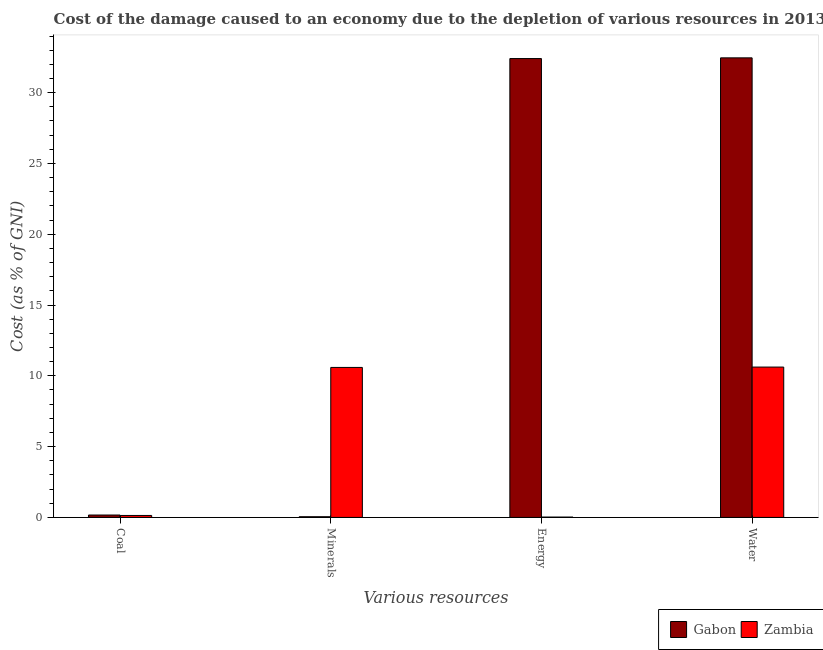How many different coloured bars are there?
Provide a succinct answer. 2. How many bars are there on the 2nd tick from the left?
Offer a very short reply. 2. What is the label of the 4th group of bars from the left?
Make the answer very short. Water. What is the cost of damage due to depletion of energy in Zambia?
Your answer should be compact. 0.03. Across all countries, what is the maximum cost of damage due to depletion of water?
Provide a short and direct response. 32.46. Across all countries, what is the minimum cost of damage due to depletion of water?
Ensure brevity in your answer.  10.62. In which country was the cost of damage due to depletion of minerals maximum?
Offer a terse response. Zambia. In which country was the cost of damage due to depletion of minerals minimum?
Provide a succinct answer. Gabon. What is the total cost of damage due to depletion of coal in the graph?
Ensure brevity in your answer.  0.31. What is the difference between the cost of damage due to depletion of energy in Zambia and that in Gabon?
Keep it short and to the point. -32.38. What is the difference between the cost of damage due to depletion of minerals in Zambia and the cost of damage due to depletion of water in Gabon?
Offer a very short reply. -21.86. What is the average cost of damage due to depletion of minerals per country?
Your answer should be very brief. 5.32. What is the difference between the cost of damage due to depletion of coal and cost of damage due to depletion of water in Gabon?
Provide a succinct answer. -32.29. What is the ratio of the cost of damage due to depletion of minerals in Gabon to that in Zambia?
Provide a succinct answer. 0. Is the cost of damage due to depletion of coal in Gabon less than that in Zambia?
Keep it short and to the point. No. What is the difference between the highest and the second highest cost of damage due to depletion of minerals?
Ensure brevity in your answer.  10.54. What is the difference between the highest and the lowest cost of damage due to depletion of water?
Offer a terse response. 21.84. In how many countries, is the cost of damage due to depletion of energy greater than the average cost of damage due to depletion of energy taken over all countries?
Provide a short and direct response. 1. Is the sum of the cost of damage due to depletion of coal in Zambia and Gabon greater than the maximum cost of damage due to depletion of minerals across all countries?
Give a very brief answer. No. Is it the case that in every country, the sum of the cost of damage due to depletion of water and cost of damage due to depletion of minerals is greater than the sum of cost of damage due to depletion of energy and cost of damage due to depletion of coal?
Keep it short and to the point. No. What does the 1st bar from the left in Coal represents?
Provide a succinct answer. Gabon. What does the 1st bar from the right in Energy represents?
Give a very brief answer. Zambia. How many bars are there?
Ensure brevity in your answer.  8. What is the difference between two consecutive major ticks on the Y-axis?
Your answer should be very brief. 5. Does the graph contain grids?
Your answer should be compact. No. Where does the legend appear in the graph?
Ensure brevity in your answer.  Bottom right. What is the title of the graph?
Your answer should be very brief. Cost of the damage caused to an economy due to the depletion of various resources in 2013 . What is the label or title of the X-axis?
Give a very brief answer. Various resources. What is the label or title of the Y-axis?
Ensure brevity in your answer.  Cost (as % of GNI). What is the Cost (as % of GNI) of Gabon in Coal?
Make the answer very short. 0.17. What is the Cost (as % of GNI) of Zambia in Coal?
Provide a short and direct response. 0.14. What is the Cost (as % of GNI) of Gabon in Minerals?
Provide a succinct answer. 0.05. What is the Cost (as % of GNI) of Zambia in Minerals?
Your answer should be very brief. 10.59. What is the Cost (as % of GNI) in Gabon in Energy?
Provide a short and direct response. 32.41. What is the Cost (as % of GNI) in Zambia in Energy?
Give a very brief answer. 0.03. What is the Cost (as % of GNI) in Gabon in Water?
Make the answer very short. 32.46. What is the Cost (as % of GNI) in Zambia in Water?
Offer a very short reply. 10.62. Across all Various resources, what is the maximum Cost (as % of GNI) of Gabon?
Offer a terse response. 32.46. Across all Various resources, what is the maximum Cost (as % of GNI) in Zambia?
Make the answer very short. 10.62. Across all Various resources, what is the minimum Cost (as % of GNI) of Gabon?
Your answer should be compact. 0.05. Across all Various resources, what is the minimum Cost (as % of GNI) of Zambia?
Give a very brief answer. 0.03. What is the total Cost (as % of GNI) of Gabon in the graph?
Give a very brief answer. 65.09. What is the total Cost (as % of GNI) of Zambia in the graph?
Your response must be concise. 21.38. What is the difference between the Cost (as % of GNI) of Gabon in Coal and that in Minerals?
Provide a short and direct response. 0.12. What is the difference between the Cost (as % of GNI) of Zambia in Coal and that in Minerals?
Give a very brief answer. -10.46. What is the difference between the Cost (as % of GNI) in Gabon in Coal and that in Energy?
Keep it short and to the point. -32.24. What is the difference between the Cost (as % of GNI) in Zambia in Coal and that in Energy?
Provide a short and direct response. 0.11. What is the difference between the Cost (as % of GNI) of Gabon in Coal and that in Water?
Your answer should be compact. -32.29. What is the difference between the Cost (as % of GNI) in Zambia in Coal and that in Water?
Provide a short and direct response. -10.48. What is the difference between the Cost (as % of GNI) in Gabon in Minerals and that in Energy?
Your answer should be compact. -32.36. What is the difference between the Cost (as % of GNI) of Zambia in Minerals and that in Energy?
Ensure brevity in your answer.  10.57. What is the difference between the Cost (as % of GNI) in Gabon in Minerals and that in Water?
Provide a succinct answer. -32.41. What is the difference between the Cost (as % of GNI) of Zambia in Minerals and that in Water?
Provide a succinct answer. -0.03. What is the difference between the Cost (as % of GNI) of Gabon in Energy and that in Water?
Make the answer very short. -0.05. What is the difference between the Cost (as % of GNI) of Zambia in Energy and that in Water?
Your response must be concise. -10.59. What is the difference between the Cost (as % of GNI) in Gabon in Coal and the Cost (as % of GNI) in Zambia in Minerals?
Make the answer very short. -10.42. What is the difference between the Cost (as % of GNI) of Gabon in Coal and the Cost (as % of GNI) of Zambia in Energy?
Your response must be concise. 0.15. What is the difference between the Cost (as % of GNI) of Gabon in Coal and the Cost (as % of GNI) of Zambia in Water?
Ensure brevity in your answer.  -10.45. What is the difference between the Cost (as % of GNI) in Gabon in Minerals and the Cost (as % of GNI) in Zambia in Energy?
Offer a very short reply. 0.02. What is the difference between the Cost (as % of GNI) in Gabon in Minerals and the Cost (as % of GNI) in Zambia in Water?
Provide a short and direct response. -10.57. What is the difference between the Cost (as % of GNI) in Gabon in Energy and the Cost (as % of GNI) in Zambia in Water?
Keep it short and to the point. 21.79. What is the average Cost (as % of GNI) of Gabon per Various resources?
Offer a very short reply. 16.27. What is the average Cost (as % of GNI) in Zambia per Various resources?
Your answer should be compact. 5.34. What is the difference between the Cost (as % of GNI) in Gabon and Cost (as % of GNI) in Zambia in Coal?
Offer a terse response. 0.03. What is the difference between the Cost (as % of GNI) of Gabon and Cost (as % of GNI) of Zambia in Minerals?
Your answer should be very brief. -10.54. What is the difference between the Cost (as % of GNI) in Gabon and Cost (as % of GNI) in Zambia in Energy?
Your response must be concise. 32.38. What is the difference between the Cost (as % of GNI) in Gabon and Cost (as % of GNI) in Zambia in Water?
Offer a very short reply. 21.84. What is the ratio of the Cost (as % of GNI) in Gabon in Coal to that in Minerals?
Offer a terse response. 3.45. What is the ratio of the Cost (as % of GNI) in Zambia in Coal to that in Minerals?
Your answer should be compact. 0.01. What is the ratio of the Cost (as % of GNI) in Gabon in Coal to that in Energy?
Make the answer very short. 0.01. What is the ratio of the Cost (as % of GNI) in Zambia in Coal to that in Energy?
Make the answer very short. 5.52. What is the ratio of the Cost (as % of GNI) of Gabon in Coal to that in Water?
Give a very brief answer. 0.01. What is the ratio of the Cost (as % of GNI) in Zambia in Coal to that in Water?
Offer a terse response. 0.01. What is the ratio of the Cost (as % of GNI) in Gabon in Minerals to that in Energy?
Provide a short and direct response. 0. What is the ratio of the Cost (as % of GNI) in Zambia in Minerals to that in Energy?
Keep it short and to the point. 422.8. What is the ratio of the Cost (as % of GNI) in Gabon in Minerals to that in Water?
Make the answer very short. 0. What is the ratio of the Cost (as % of GNI) of Gabon in Energy to that in Water?
Provide a short and direct response. 1. What is the ratio of the Cost (as % of GNI) of Zambia in Energy to that in Water?
Provide a succinct answer. 0. What is the difference between the highest and the second highest Cost (as % of GNI) of Gabon?
Provide a short and direct response. 0.05. What is the difference between the highest and the second highest Cost (as % of GNI) of Zambia?
Provide a succinct answer. 0.03. What is the difference between the highest and the lowest Cost (as % of GNI) of Gabon?
Offer a terse response. 32.41. What is the difference between the highest and the lowest Cost (as % of GNI) in Zambia?
Make the answer very short. 10.59. 